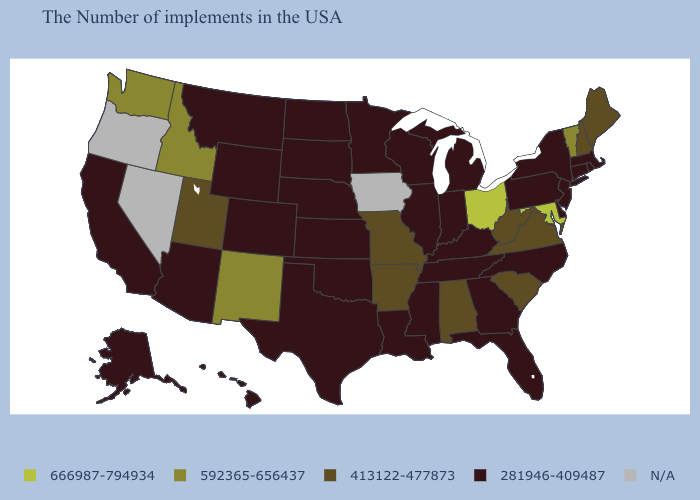What is the value of Iowa?
Short answer required. N/A. What is the lowest value in states that border Utah?
Quick response, please. 281946-409487. What is the highest value in the West ?
Answer briefly. 592365-656437. Among the states that border South Carolina , which have the highest value?
Answer briefly. North Carolina, Georgia. What is the value of Massachusetts?
Keep it brief. 281946-409487. What is the value of Oklahoma?
Be succinct. 281946-409487. Which states hav the highest value in the South?
Give a very brief answer. Maryland. What is the highest value in the USA?
Give a very brief answer. 666987-794934. What is the lowest value in states that border Indiana?
Keep it brief. 281946-409487. What is the lowest value in the MidWest?
Answer briefly. 281946-409487. Which states have the lowest value in the South?
Give a very brief answer. Delaware, North Carolina, Florida, Georgia, Kentucky, Tennessee, Mississippi, Louisiana, Oklahoma, Texas. Does West Virginia have the lowest value in the South?
Keep it brief. No. What is the value of Oklahoma?
Give a very brief answer. 281946-409487. What is the highest value in the USA?
Write a very short answer. 666987-794934. Which states have the lowest value in the West?
Keep it brief. Wyoming, Colorado, Montana, Arizona, California, Alaska, Hawaii. 